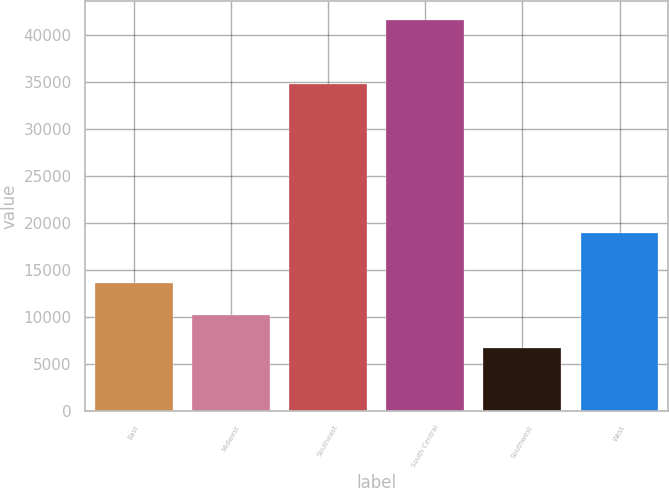Convert chart to OTSL. <chart><loc_0><loc_0><loc_500><loc_500><bar_chart><fcel>East<fcel>Midwest<fcel>Southeast<fcel>South Central<fcel>Southwest<fcel>West<nl><fcel>13680<fcel>10190<fcel>34800<fcel>41600<fcel>6700<fcel>19000<nl></chart> 